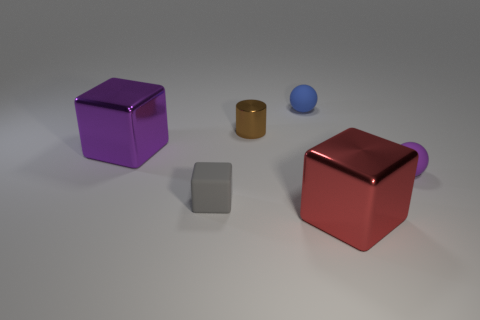The lighting in the room seems a bit dim, can you comment on that? The lighting in the image appears soft and indirect, creating gentle shadows and a calming ambiance. There's no harsh or direct light, which might suggest an environment meant for showcasing or perhaps photography. 